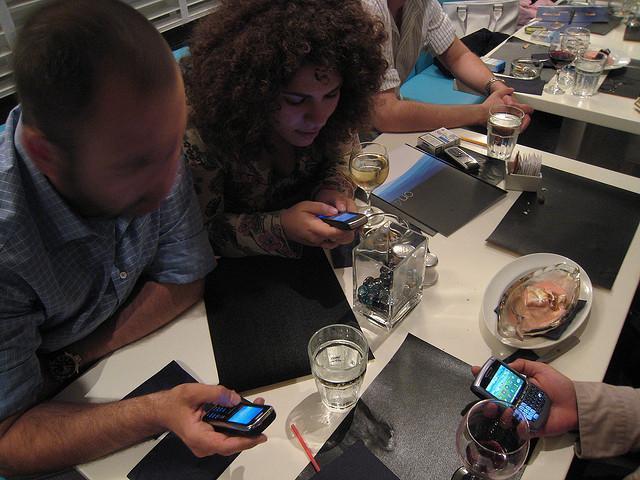How many people have phones?
Give a very brief answer. 3. How many people are in the photo?
Give a very brief answer. 4. How many wine glasses are there?
Give a very brief answer. 2. How many dining tables are visible?
Give a very brief answer. 2. 